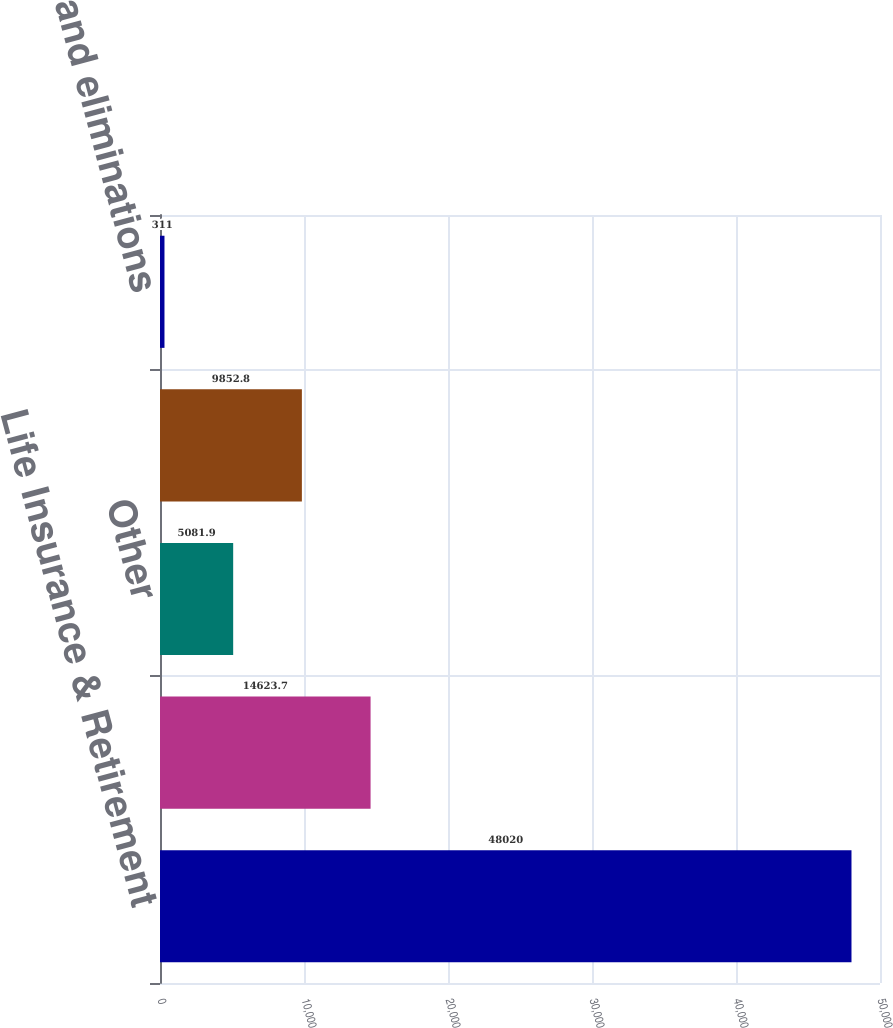Convert chart. <chart><loc_0><loc_0><loc_500><loc_500><bar_chart><fcel>Life Insurance & Retirement<fcel>Asset Management<fcel>Other<fcel>General Insurance (c)<fcel>Consolidation and eliminations<nl><fcel>48020<fcel>14623.7<fcel>5081.9<fcel>9852.8<fcel>311<nl></chart> 